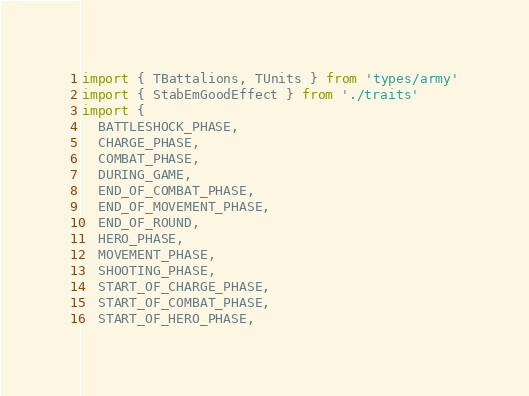Convert code to text. <code><loc_0><loc_0><loc_500><loc_500><_TypeScript_>import { TBattalions, TUnits } from 'types/army'
import { StabEmGoodEffect } from './traits'
import {
  BATTLESHOCK_PHASE,
  CHARGE_PHASE,
  COMBAT_PHASE,
  DURING_GAME,
  END_OF_COMBAT_PHASE,
  END_OF_MOVEMENT_PHASE,
  END_OF_ROUND,
  HERO_PHASE,
  MOVEMENT_PHASE,
  SHOOTING_PHASE,
  START_OF_CHARGE_PHASE,
  START_OF_COMBAT_PHASE,
  START_OF_HERO_PHASE,</code> 